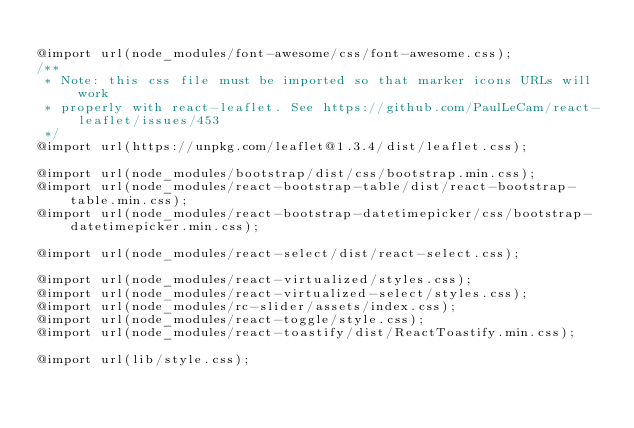<code> <loc_0><loc_0><loc_500><loc_500><_CSS_>
@import url(node_modules/font-awesome/css/font-awesome.css);
/**
 * Note: this css file must be imported so that marker icons URLs will work
 * properly with react-leaflet. See https://github.com/PaulLeCam/react-leaflet/issues/453
 */
@import url(https://unpkg.com/leaflet@1.3.4/dist/leaflet.css);

@import url(node_modules/bootstrap/dist/css/bootstrap.min.css);
@import url(node_modules/react-bootstrap-table/dist/react-bootstrap-table.min.css);
@import url(node_modules/react-bootstrap-datetimepicker/css/bootstrap-datetimepicker.min.css);

@import url(node_modules/react-select/dist/react-select.css);

@import url(node_modules/react-virtualized/styles.css);
@import url(node_modules/react-virtualized-select/styles.css);
@import url(node_modules/rc-slider/assets/index.css);
@import url(node_modules/react-toggle/style.css);
@import url(node_modules/react-toastify/dist/ReactToastify.min.css);

@import url(lib/style.css);
</code> 